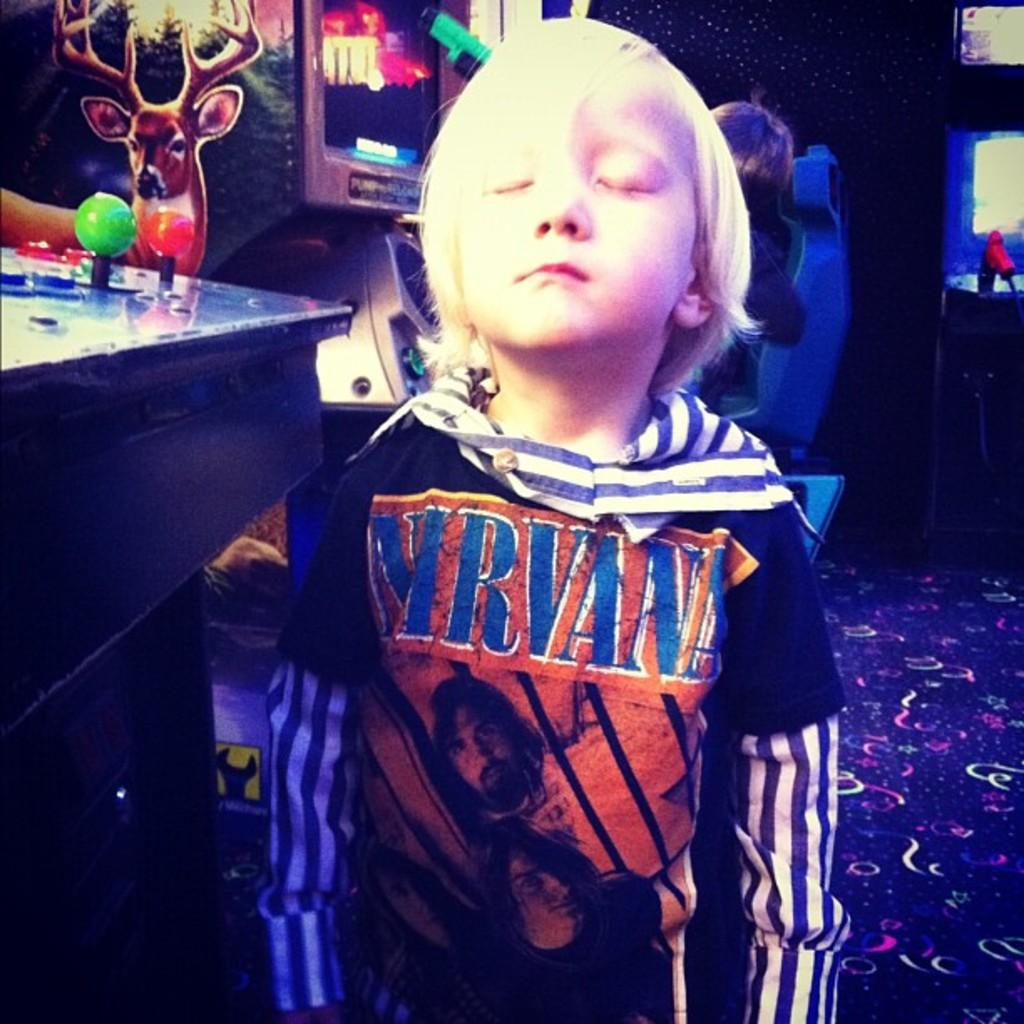Provide a one-sentence caption for the provided image. A little blonde boy with Nirvana on his shirt. 